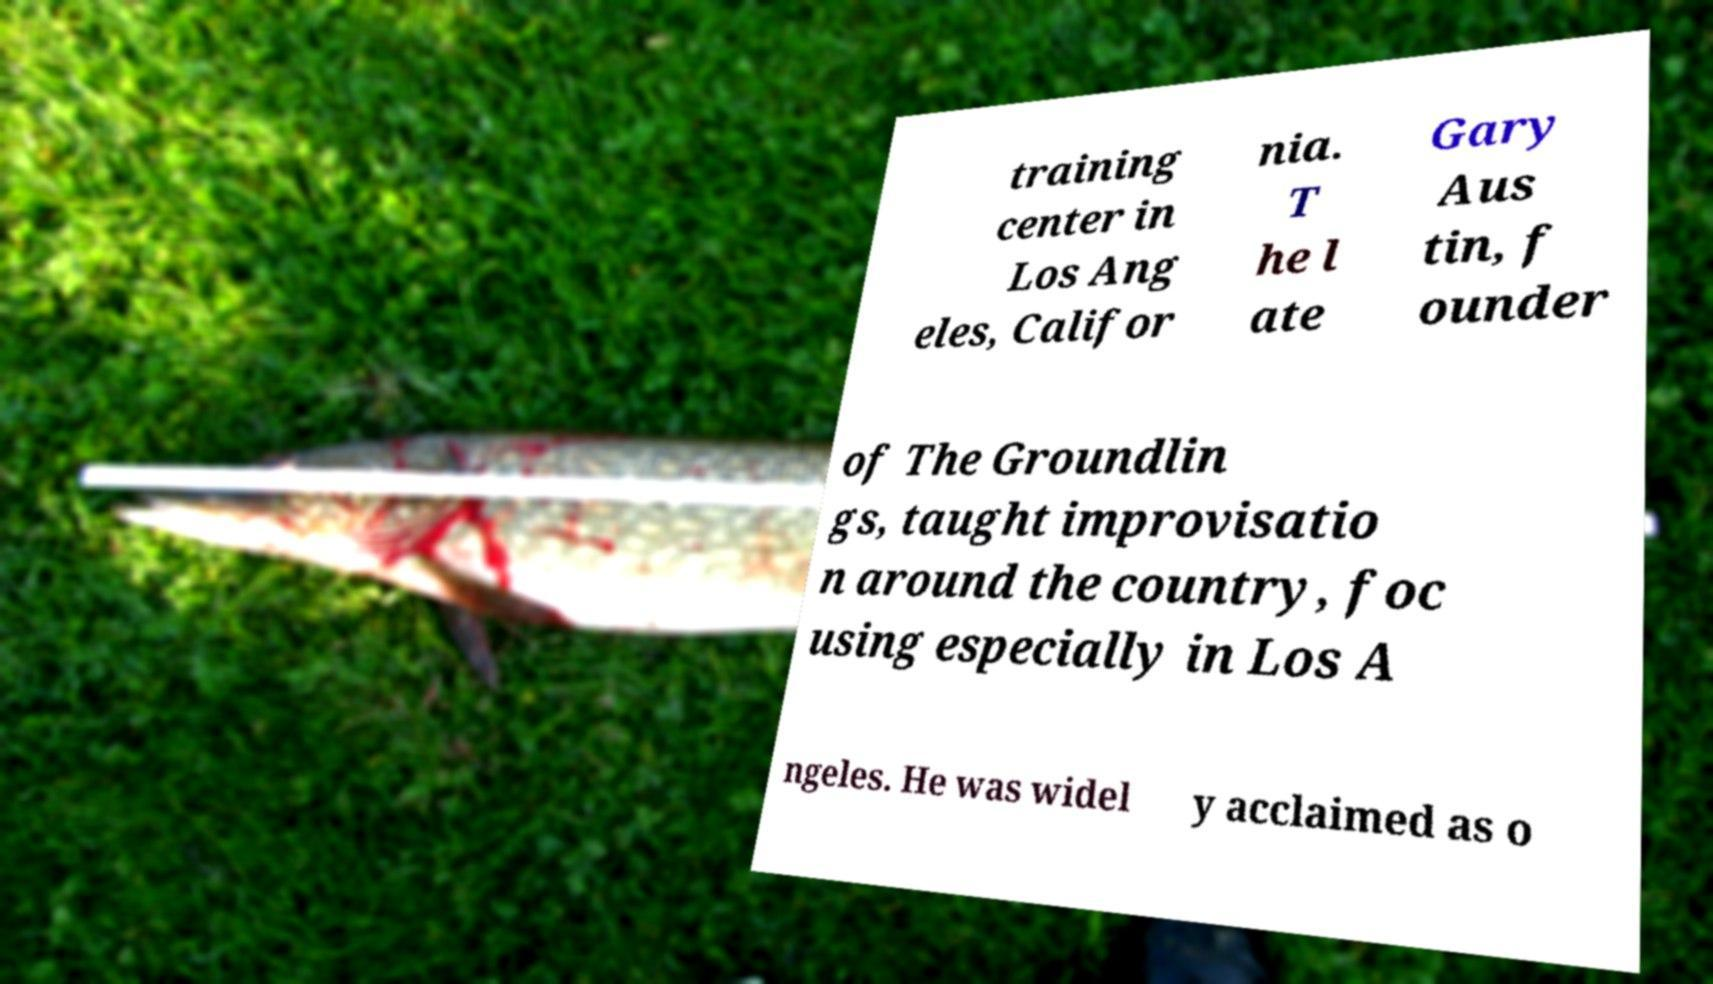I need the written content from this picture converted into text. Can you do that? training center in Los Ang eles, Califor nia. T he l ate Gary Aus tin, f ounder of The Groundlin gs, taught improvisatio n around the country, foc using especially in Los A ngeles. He was widel y acclaimed as o 